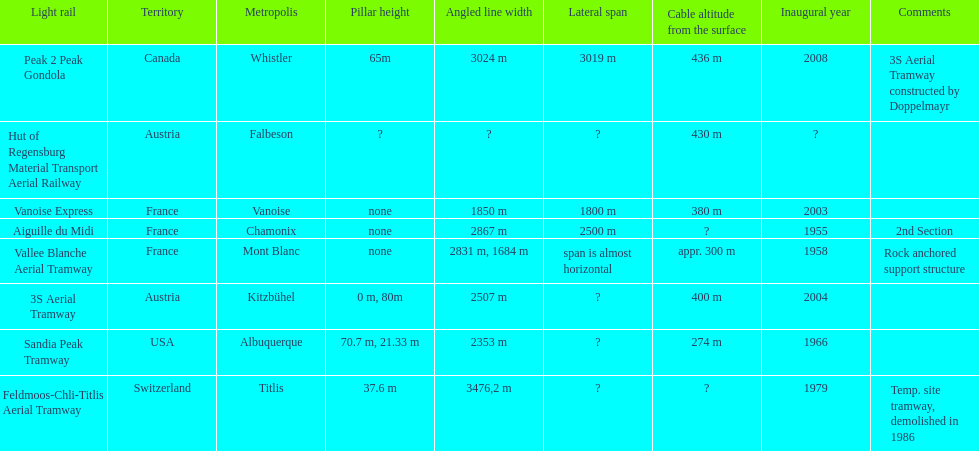Which tramway was built directly before the 3s aeriral tramway? Vanoise Express. 